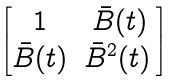<formula> <loc_0><loc_0><loc_500><loc_500>\begin{bmatrix} 1 & \bar { B } ( t ) \\ \bar { B } ( t ) & \bar { B } ^ { 2 } ( t ) \, \end{bmatrix}</formula> 